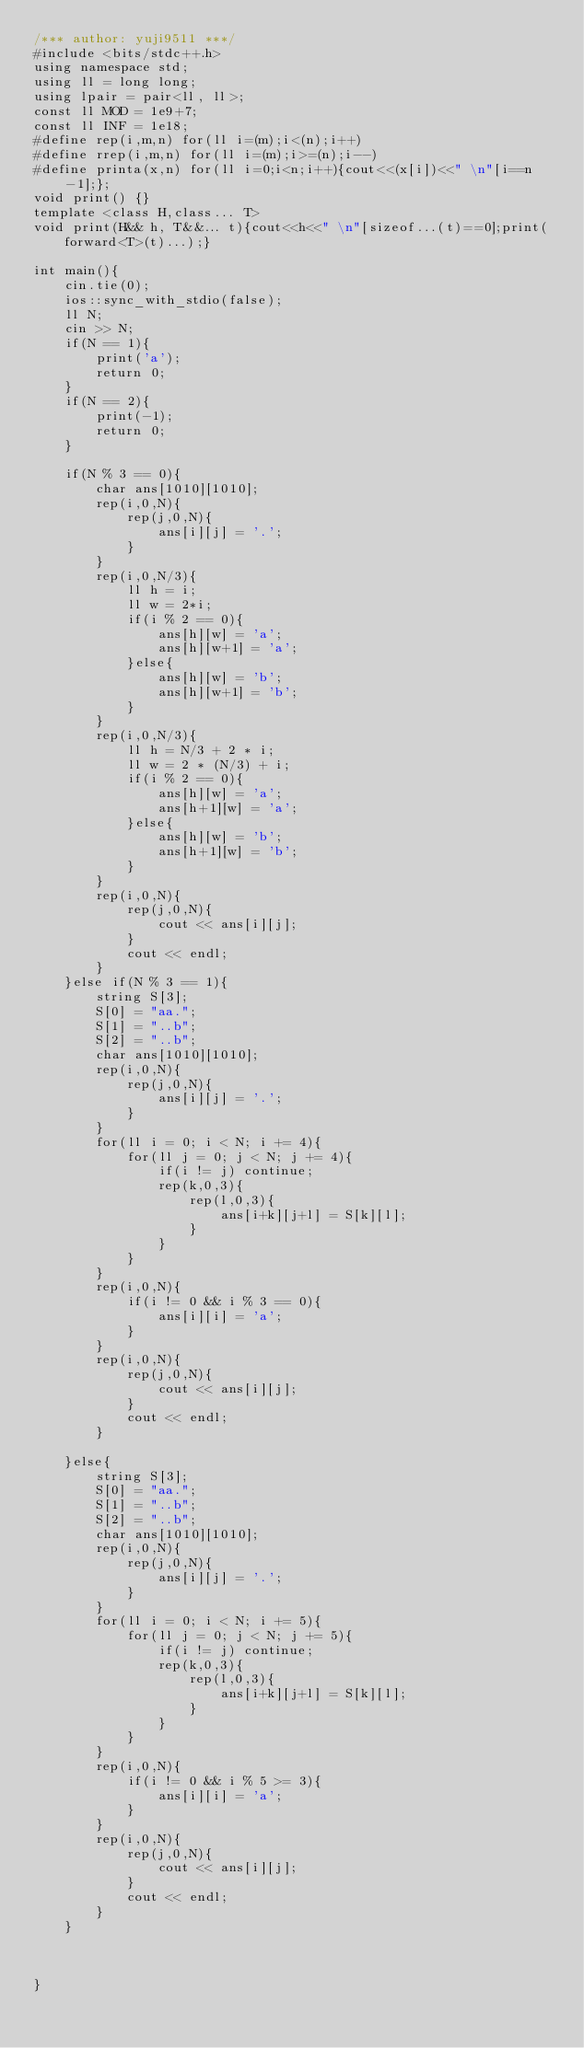<code> <loc_0><loc_0><loc_500><loc_500><_C++_>/*** author: yuji9511 ***/
#include <bits/stdc++.h>
using namespace std;
using ll = long long;
using lpair = pair<ll, ll>;
const ll MOD = 1e9+7;
const ll INF = 1e18;
#define rep(i,m,n) for(ll i=(m);i<(n);i++)
#define rrep(i,m,n) for(ll i=(m);i>=(n);i--)
#define printa(x,n) for(ll i=0;i<n;i++){cout<<(x[i])<<" \n"[i==n-1];};
void print() {}
template <class H,class... T>
void print(H&& h, T&&... t){cout<<h<<" \n"[sizeof...(t)==0];print(forward<T>(t)...);}

int main(){
    cin.tie(0);
    ios::sync_with_stdio(false);
    ll N;
    cin >> N;
    if(N == 1){
        print('a');
        return 0;
    }
    if(N == 2){
        print(-1);
        return 0;
    }

    if(N % 3 == 0){
        char ans[1010][1010];
        rep(i,0,N){
            rep(j,0,N){
                ans[i][j] = '.';
            }
        }
        rep(i,0,N/3){
            ll h = i;
            ll w = 2*i;
            if(i % 2 == 0){
                ans[h][w] = 'a';
                ans[h][w+1] = 'a';
            }else{
                ans[h][w] = 'b';
                ans[h][w+1] = 'b';     
            }
        }
        rep(i,0,N/3){
            ll h = N/3 + 2 * i;
            ll w = 2 * (N/3) + i;
            if(i % 2 == 0){
                ans[h][w] = 'a';
                ans[h+1][w] = 'a';
            }else{
                ans[h][w] = 'b';
                ans[h+1][w] = 'b';          
            }
        }
        rep(i,0,N){
            rep(j,0,N){
                cout << ans[i][j];
            }
            cout << endl;
        }
    }else if(N % 3 == 1){
        string S[3];
        S[0] = "aa.";
        S[1] = "..b";
        S[2] = "..b";
        char ans[1010][1010];
        rep(i,0,N){
            rep(j,0,N){
                ans[i][j] = '.';
            }
        }
        for(ll i = 0; i < N; i += 4){
            for(ll j = 0; j < N; j += 4){
                if(i != j) continue;
                rep(k,0,3){
                    rep(l,0,3){
                        ans[i+k][j+l] = S[k][l];
                    }
                }
            }
        }
        rep(i,0,N){
            if(i != 0 && i % 3 == 0){
                ans[i][i] = 'a';
            }
        }
        rep(i,0,N){
            rep(j,0,N){
                cout << ans[i][j];
            }
            cout << endl;
        }

    }else{
        string S[3];
        S[0] = "aa.";
        S[1] = "..b";
        S[2] = "..b";
        char ans[1010][1010];
        rep(i,0,N){
            rep(j,0,N){
                ans[i][j] = '.';
            }
        }
        for(ll i = 0; i < N; i += 5){
            for(ll j = 0; j < N; j += 5){
                if(i != j) continue;
                rep(k,0,3){
                    rep(l,0,3){
                        ans[i+k][j+l] = S[k][l];
                    }
                }
            }
        }
        rep(i,0,N){
            if(i != 0 && i % 5 >= 3){
                ans[i][i] = 'a';
            }
        }
        rep(i,0,N){
            rep(j,0,N){
                cout << ans[i][j];
            }
            cout << endl;
        }     
    }

    

}
</code> 